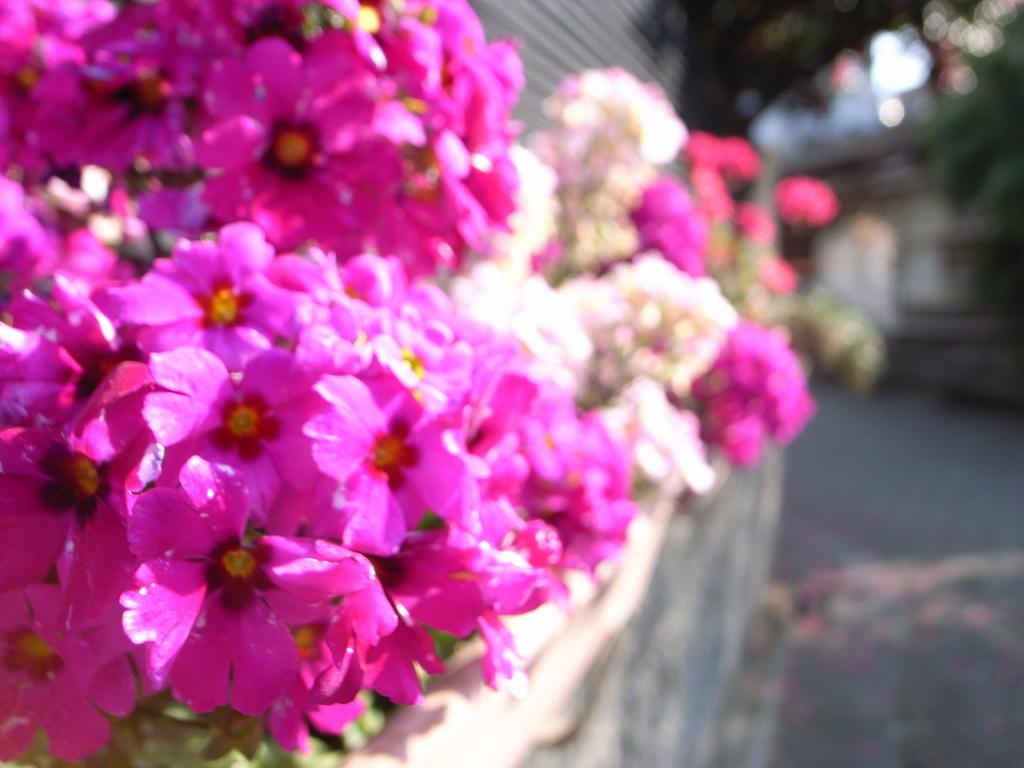What color are the flowers in the image? The flowers in the image are pink. Can you describe the background of the image? The background of the image is blurred. How does the beginner learn to shake the shoe in the image? There is no beginner, shaking, or shoe present in the image. 